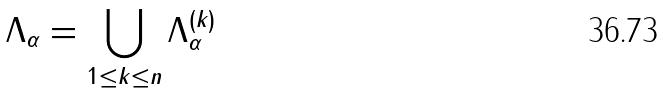<formula> <loc_0><loc_0><loc_500><loc_500>\Lambda _ { \alpha } = \bigcup _ { 1 \leq k \leq n } \Lambda _ { \alpha } ^ { ( k ) }</formula> 